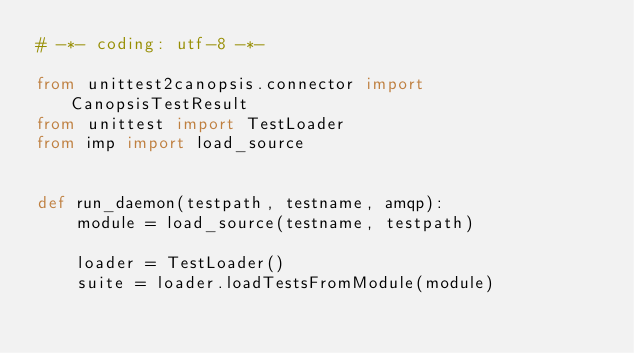Convert code to text. <code><loc_0><loc_0><loc_500><loc_500><_Python_># -*- coding: utf-8 -*-

from unittest2canopsis.connector import CanopsisTestResult
from unittest import TestLoader
from imp import load_source


def run_daemon(testpath, testname, amqp):
    module = load_source(testname, testpath)

    loader = TestLoader()
    suite = loader.loadTestsFromModule(module)</code> 